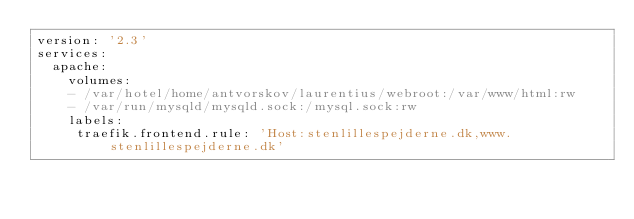Convert code to text. <code><loc_0><loc_0><loc_500><loc_500><_YAML_>version: '2.3'
services:
  apache:
    volumes:
    - /var/hotel/home/antvorskov/laurentius/webroot:/var/www/html:rw
    - /var/run/mysqld/mysqld.sock:/mysql.sock:rw
    labels:
     traefik.frontend.rule: 'Host:stenlillespejderne.dk,www.stenlillespejderne.dk'
</code> 